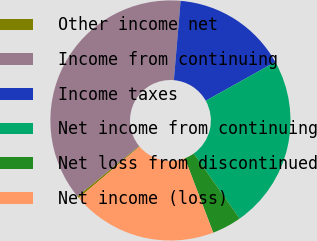<chart> <loc_0><loc_0><loc_500><loc_500><pie_chart><fcel>Other income net<fcel>Income from continuing<fcel>Income taxes<fcel>Net income from continuing<fcel>Net loss from discontinued<fcel>Net income (loss)<nl><fcel>0.29%<fcel>37.23%<fcel>15.55%<fcel>23.32%<fcel>3.98%<fcel>19.63%<nl></chart> 